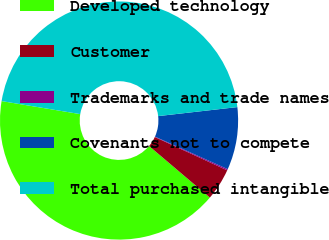Convert chart to OTSL. <chart><loc_0><loc_0><loc_500><loc_500><pie_chart><fcel>Developed technology<fcel>Customer<fcel>Trademarks and trade names<fcel>Covenants not to compete<fcel>Total purchased intangible<nl><fcel>41.42%<fcel>4.33%<fcel>0.17%<fcel>8.5%<fcel>45.58%<nl></chart> 